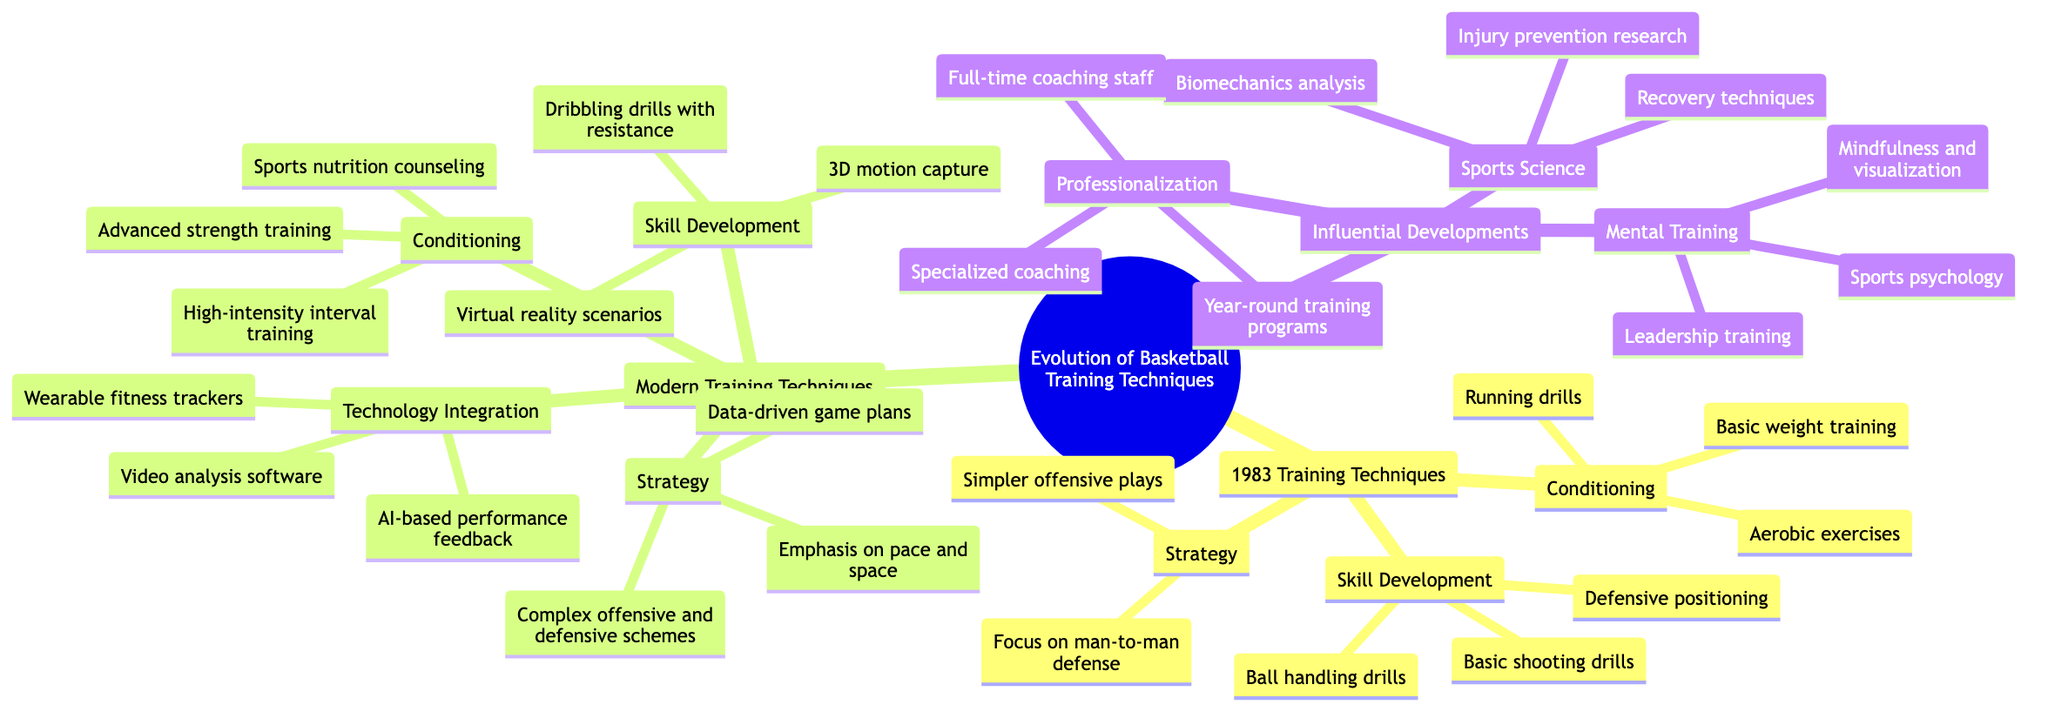What are the three main branches of the mind map? The main branches are listed as: "1983 Training Techniques," "Modern Training Techniques," and "Influential Developments."
Answer: 1983 Training Techniques, Modern Training Techniques, Influential Developments How many sub-branches are under "Modern Training Techniques"? The sub-branches under "Modern Training Techniques" are Conditioning, Skill Development, Technology Integration, and Strategy. Counting these, we find there are four sub-branches.
Answer: 4 What specific training method is mentioned under "1983 Training Techniques" for Conditioning? The details under "1983 Training Techniques" for Conditioning include Running drills, Basic weight training, and Aerobic exercises. Among these, "Running drills" is a specific method mentioned.
Answer: Running drills Which modern technique involves the use of technology for player feedback? Looking at the "Technology Integration" sub-branch under "Modern Training Techniques," "AI-based performance feedback" is identified as a modern technique utilizing technology.
Answer: AI-based performance feedback What aspect of training includes "Injury prevention research"? Under "Influential Developments," the sub-branch "Sports Science" mentions "Injury prevention research" as a key component.
Answer: Sports Science Which type of training focuses on "Mindfulness and visualization"? The sub-branch "Mental Training" under "Influential Developments" specifically includes "Mindfulness and visualization" as part of its focus.
Answer: Mental Training Which training technique from the 1983 era focuses on defensive positioning? Under the "Skill Development" branch of "1983 Training Techniques", "Defensive positioning" is explicitly mentioned as a technique from that era.
Answer: Defensive positioning What is included in the "Complex offensive and defensive schemes" description? This details are found in the "Strategy" sub-branch of "Modern Training Techniques" that indicates a shift towards more sophisticated plays compared to earlier strategies.
Answer: Complex offensive and defensive schemes 